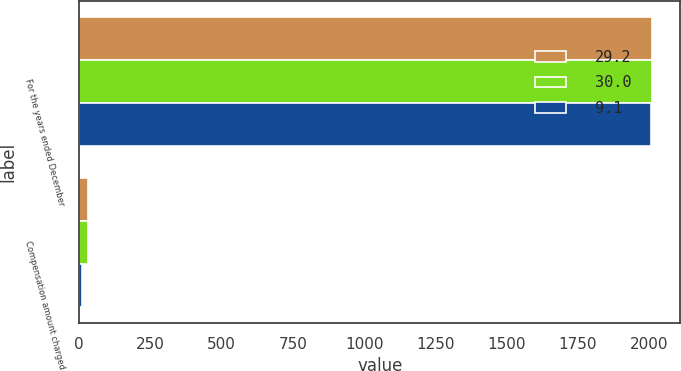Convert chart. <chart><loc_0><loc_0><loc_500><loc_500><stacked_bar_chart><ecel><fcel>For the years ended December<fcel>Compensation amount charged<nl><fcel>29.2<fcel>2010<fcel>29.2<nl><fcel>30<fcel>2009<fcel>30<nl><fcel>9.1<fcel>2008<fcel>9.1<nl></chart> 